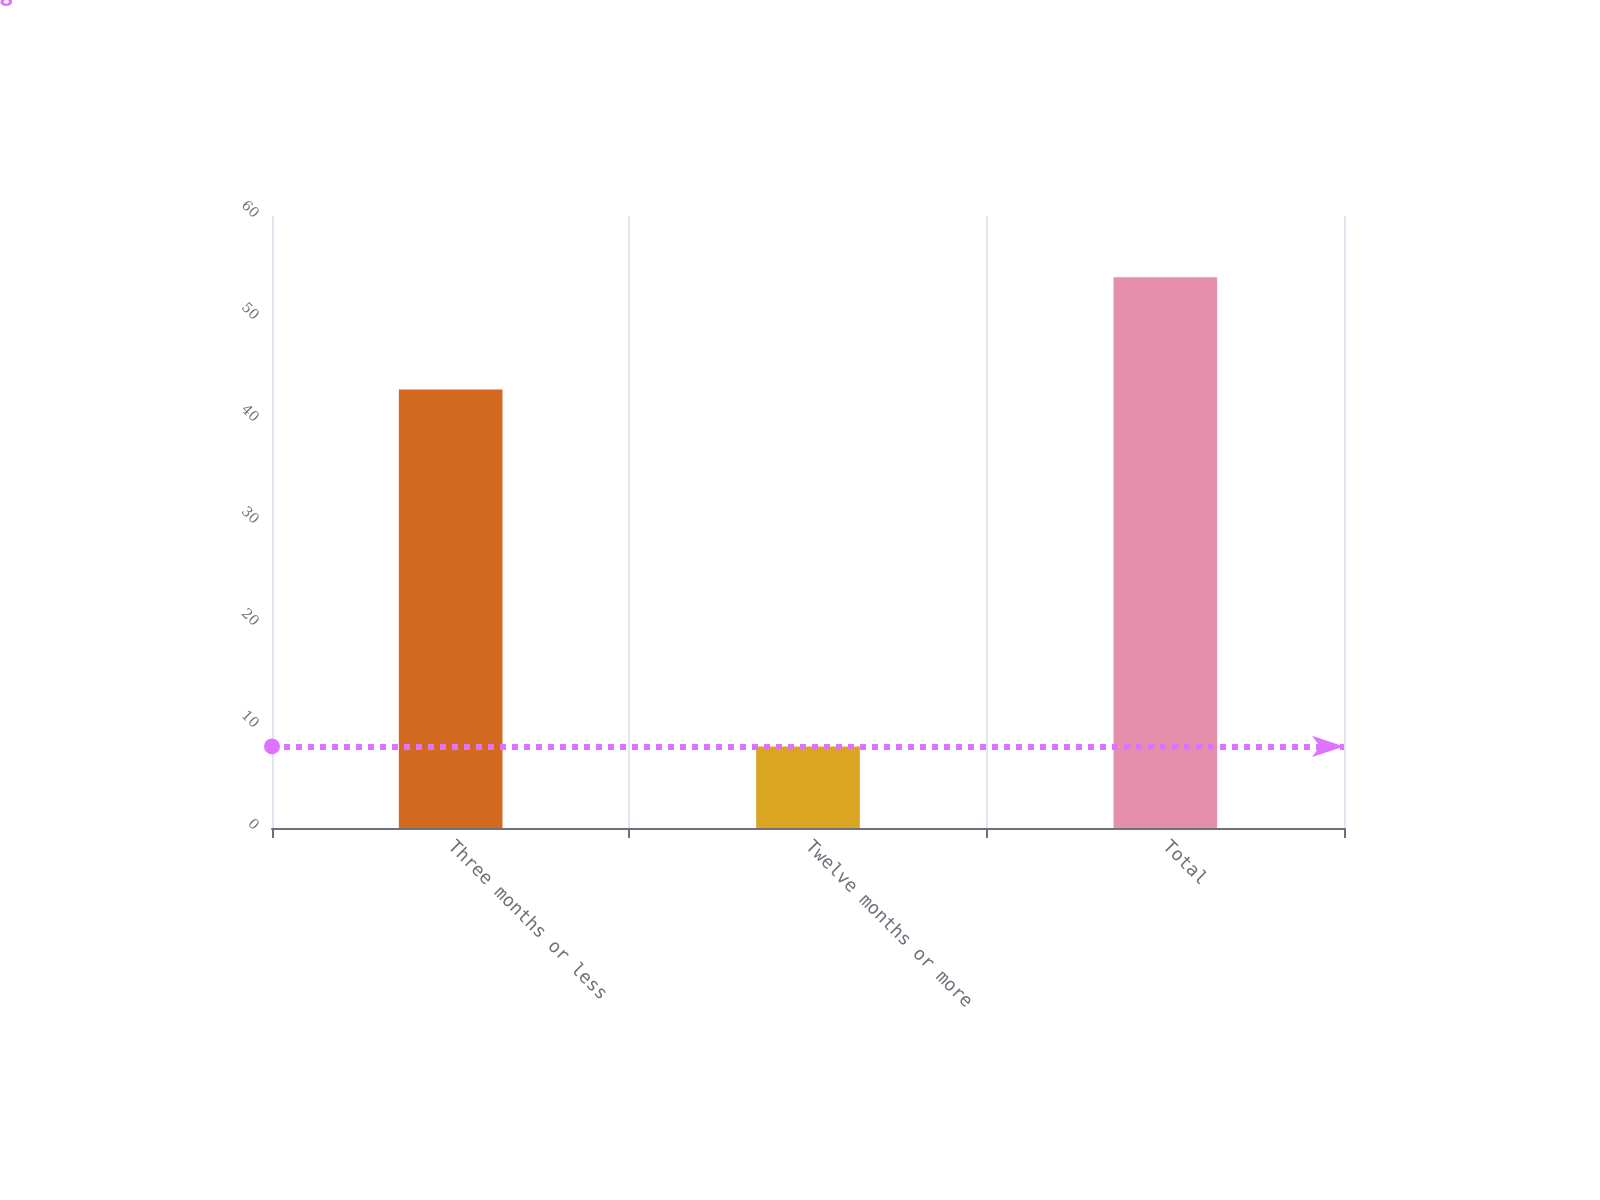Convert chart to OTSL. <chart><loc_0><loc_0><loc_500><loc_500><bar_chart><fcel>Three months or less<fcel>Twelve months or more<fcel>Total<nl><fcel>43<fcel>8<fcel>54<nl></chart> 